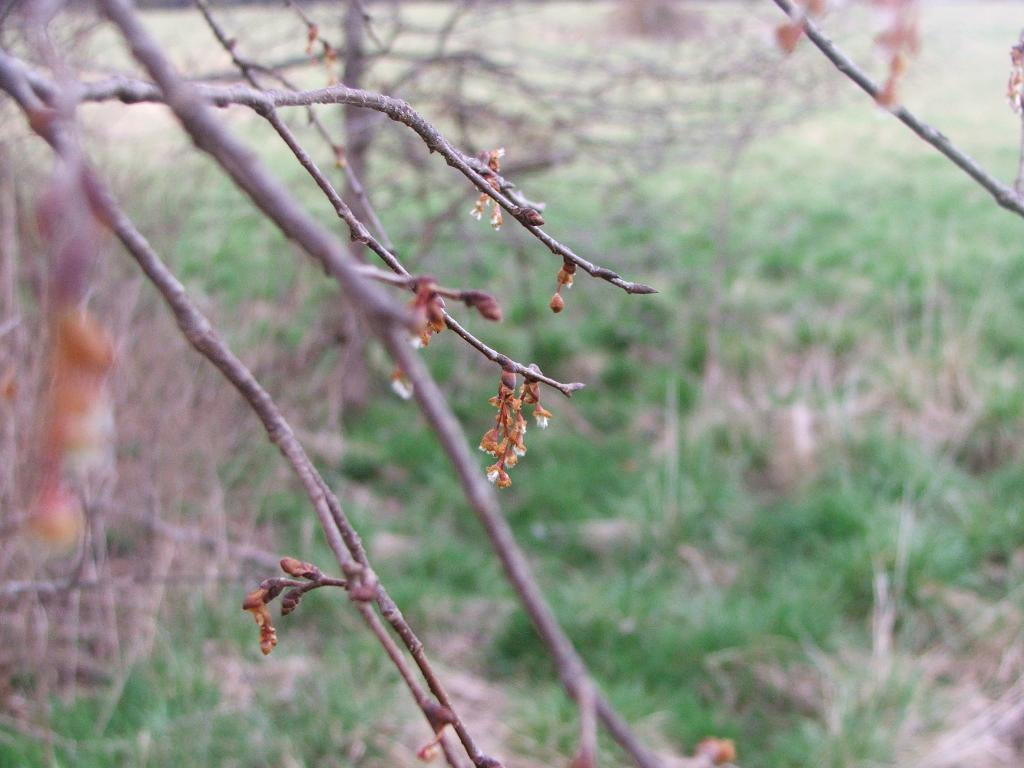What type of vegetation can be seen in the image? There are trees and grass in the image. Are there any plants with flowers in the image? Yes, there are flowers on the branches of the trees. How many chickens are sitting on the lettuce in the image? There is no lettuce or chickens present in the image. Can you tell me the name of the uncle who is watering the flowers in the image? There is no uncle present in the image, and the fact of watering the flowers is not mentioned. 